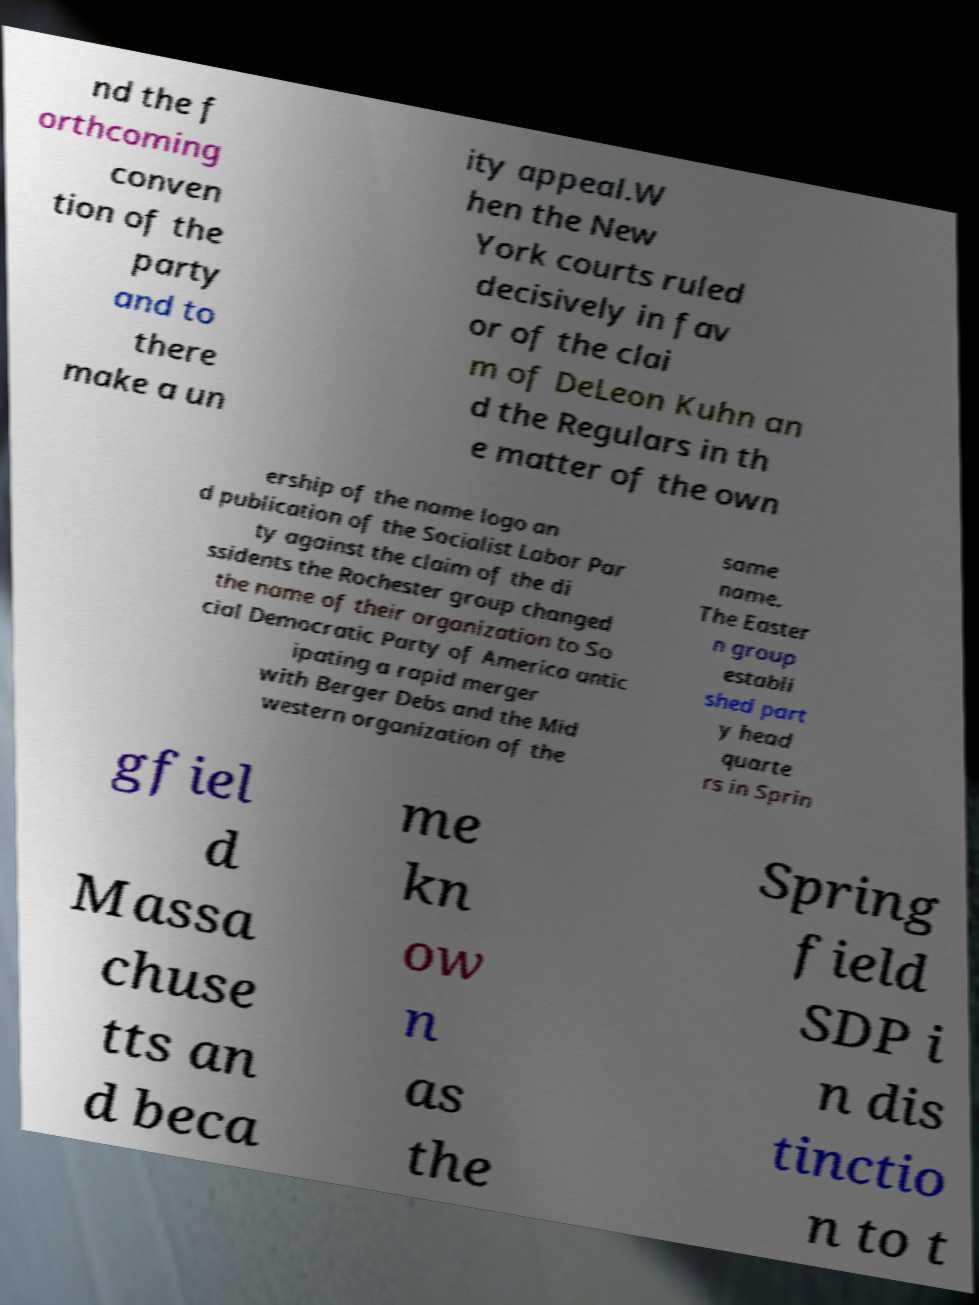Could you extract and type out the text from this image? nd the f orthcoming conven tion of the party and to there make a un ity appeal.W hen the New York courts ruled decisively in fav or of the clai m of DeLeon Kuhn an d the Regulars in th e matter of the own ership of the name logo an d publication of the Socialist Labor Par ty against the claim of the di ssidents the Rochester group changed the name of their organization to So cial Democratic Party of America antic ipating a rapid merger with Berger Debs and the Mid western organization of the same name. The Easter n group establi shed part y head quarte rs in Sprin gfiel d Massa chuse tts an d beca me kn ow n as the Spring field SDP i n dis tinctio n to t 